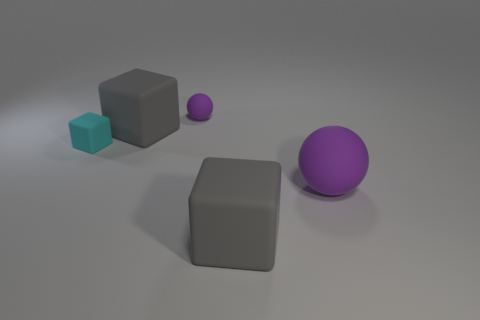Add 2 matte things. How many objects exist? 7 Subtract all blocks. How many objects are left? 2 Add 2 matte blocks. How many matte blocks are left? 5 Add 4 big gray rubber cubes. How many big gray rubber cubes exist? 6 Subtract 0 purple cylinders. How many objects are left? 5 Subtract all large purple balls. Subtract all big gray things. How many objects are left? 2 